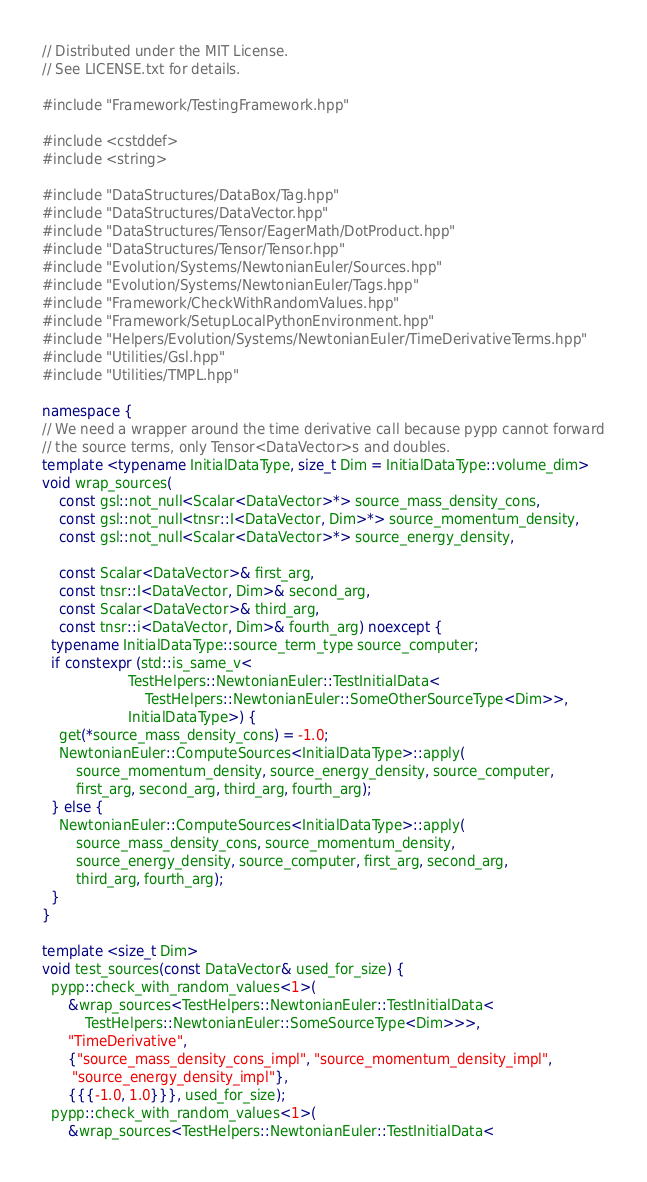Convert code to text. <code><loc_0><loc_0><loc_500><loc_500><_C++_>// Distributed under the MIT License.
// See LICENSE.txt for details.

#include "Framework/TestingFramework.hpp"

#include <cstddef>
#include <string>

#include "DataStructures/DataBox/Tag.hpp"
#include "DataStructures/DataVector.hpp"
#include "DataStructures/Tensor/EagerMath/DotProduct.hpp"
#include "DataStructures/Tensor/Tensor.hpp"
#include "Evolution/Systems/NewtonianEuler/Sources.hpp"
#include "Evolution/Systems/NewtonianEuler/Tags.hpp"
#include "Framework/CheckWithRandomValues.hpp"
#include "Framework/SetupLocalPythonEnvironment.hpp"
#include "Helpers/Evolution/Systems/NewtonianEuler/TimeDerivativeTerms.hpp"
#include "Utilities/Gsl.hpp"
#include "Utilities/TMPL.hpp"

namespace {
// We need a wrapper around the time derivative call because pypp cannot forward
// the source terms, only Tensor<DataVector>s and doubles.
template <typename InitialDataType, size_t Dim = InitialDataType::volume_dim>
void wrap_sources(
    const gsl::not_null<Scalar<DataVector>*> source_mass_density_cons,
    const gsl::not_null<tnsr::I<DataVector, Dim>*> source_momentum_density,
    const gsl::not_null<Scalar<DataVector>*> source_energy_density,

    const Scalar<DataVector>& first_arg,
    const tnsr::I<DataVector, Dim>& second_arg,
    const Scalar<DataVector>& third_arg,
    const tnsr::i<DataVector, Dim>& fourth_arg) noexcept {
  typename InitialDataType::source_term_type source_computer;
  if constexpr (std::is_same_v<
                    TestHelpers::NewtonianEuler::TestInitialData<
                        TestHelpers::NewtonianEuler::SomeOtherSourceType<Dim>>,
                    InitialDataType>) {
    get(*source_mass_density_cons) = -1.0;
    NewtonianEuler::ComputeSources<InitialDataType>::apply(
        source_momentum_density, source_energy_density, source_computer,
        first_arg, second_arg, third_arg, fourth_arg);
  } else {
    NewtonianEuler::ComputeSources<InitialDataType>::apply(
        source_mass_density_cons, source_momentum_density,
        source_energy_density, source_computer, first_arg, second_arg,
        third_arg, fourth_arg);
  }
}

template <size_t Dim>
void test_sources(const DataVector& used_for_size) {
  pypp::check_with_random_values<1>(
      &wrap_sources<TestHelpers::NewtonianEuler::TestInitialData<
          TestHelpers::NewtonianEuler::SomeSourceType<Dim>>>,
      "TimeDerivative",
      {"source_mass_density_cons_impl", "source_momentum_density_impl",
       "source_energy_density_impl"},
      {{{-1.0, 1.0}}}, used_for_size);
  pypp::check_with_random_values<1>(
      &wrap_sources<TestHelpers::NewtonianEuler::TestInitialData<</code> 